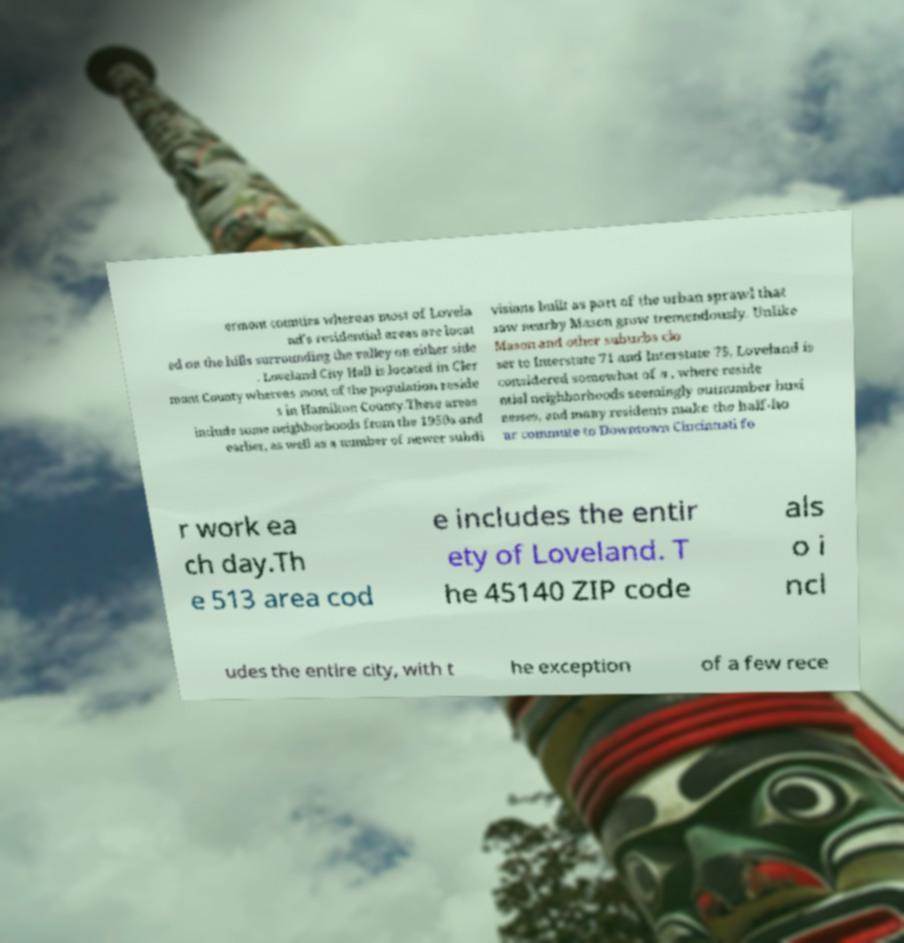There's text embedded in this image that I need extracted. Can you transcribe it verbatim? ermont counties whereas most of Lovela nd's residential areas are locat ed on the hills surrounding the valley on either side . Loveland City Hall is located in Cler mont County whereas most of the population reside s in Hamilton County.These areas include some neighborhoods from the 1950s and earlier, as well as a number of newer subdi visions built as part of the urban sprawl that saw nearby Mason grow tremendously. Unlike Mason and other suburbs clo ser to Interstate 71 and Interstate 75, Loveland is considered somewhat of a , where reside ntial neighborhoods seemingly outnumber busi nesses, and many residents make the half-ho ur commute to Downtown Cincinnati fo r work ea ch day.Th e 513 area cod e includes the entir ety of Loveland. T he 45140 ZIP code als o i ncl udes the entire city, with t he exception of a few rece 